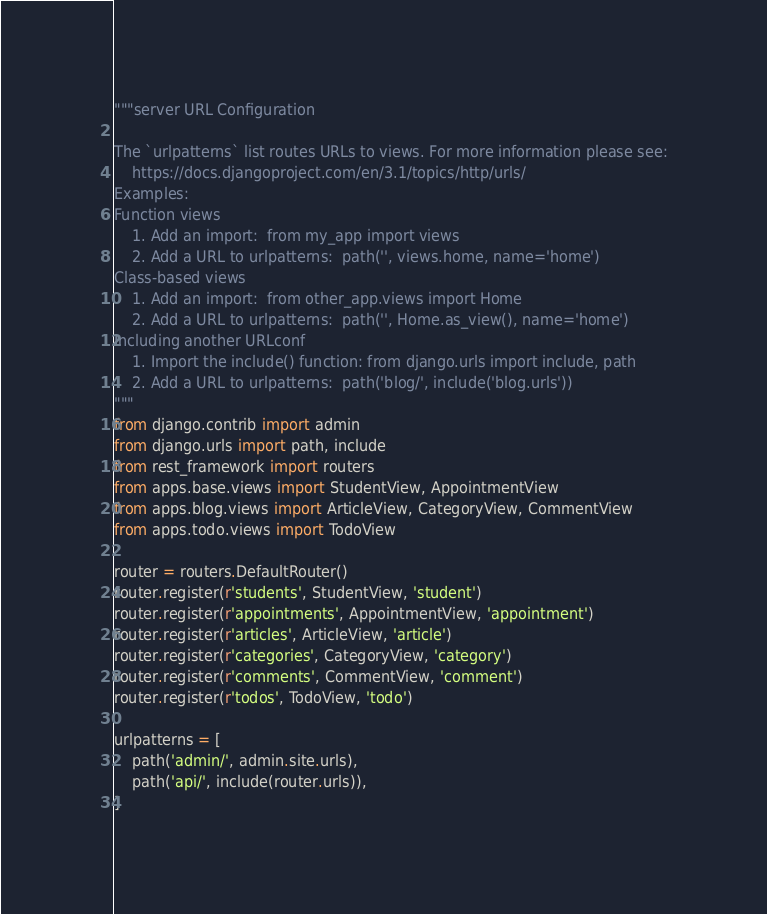<code> <loc_0><loc_0><loc_500><loc_500><_Python_>"""server URL Configuration

The `urlpatterns` list routes URLs to views. For more information please see:
    https://docs.djangoproject.com/en/3.1/topics/http/urls/
Examples:
Function views
    1. Add an import:  from my_app import views
    2. Add a URL to urlpatterns:  path('', views.home, name='home')
Class-based views
    1. Add an import:  from other_app.views import Home
    2. Add a URL to urlpatterns:  path('', Home.as_view(), name='home')
Including another URLconf
    1. Import the include() function: from django.urls import include, path
    2. Add a URL to urlpatterns:  path('blog/', include('blog.urls'))
"""
from django.contrib import admin
from django.urls import path, include
from rest_framework import routers
from apps.base.views import StudentView, AppointmentView
from apps.blog.views import ArticleView, CategoryView, CommentView
from apps.todo.views import TodoView

router = routers.DefaultRouter()
router.register(r'students', StudentView, 'student')
router.register(r'appointments', AppointmentView, 'appointment')
router.register(r'articles', ArticleView, 'article')
router.register(r'categories', CategoryView, 'category')
router.register(r'comments', CommentView, 'comment')
router.register(r'todos', TodoView, 'todo')

urlpatterns = [
    path('admin/', admin.site.urls),
    path('api/', include(router.urls)),
]
</code> 